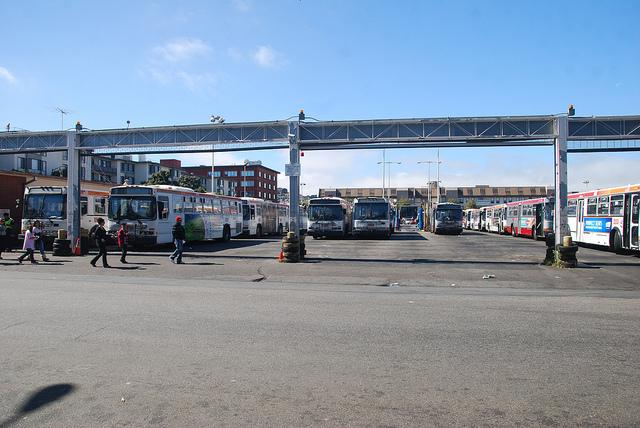How many rows of buses are visible? Please explain your reasoning. six. There are six rows of busses visible. 